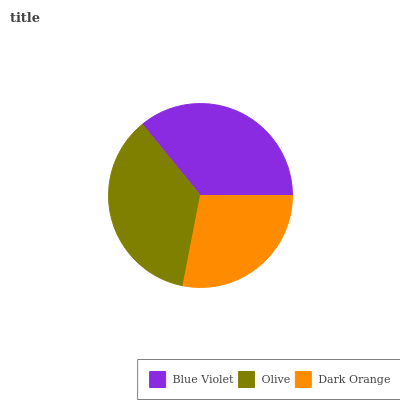Is Dark Orange the minimum?
Answer yes or no. Yes. Is Olive the maximum?
Answer yes or no. Yes. Is Olive the minimum?
Answer yes or no. No. Is Dark Orange the maximum?
Answer yes or no. No. Is Olive greater than Dark Orange?
Answer yes or no. Yes. Is Dark Orange less than Olive?
Answer yes or no. Yes. Is Dark Orange greater than Olive?
Answer yes or no. No. Is Olive less than Dark Orange?
Answer yes or no. No. Is Blue Violet the high median?
Answer yes or no. Yes. Is Blue Violet the low median?
Answer yes or no. Yes. Is Olive the high median?
Answer yes or no. No. Is Dark Orange the low median?
Answer yes or no. No. 